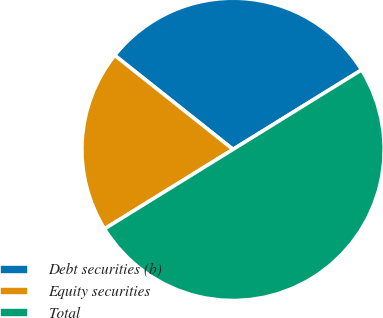Convert chart. <chart><loc_0><loc_0><loc_500><loc_500><pie_chart><fcel>Debt securities (b)<fcel>Equity securities<fcel>Total<nl><fcel>30.5%<fcel>19.5%<fcel>50.0%<nl></chart> 